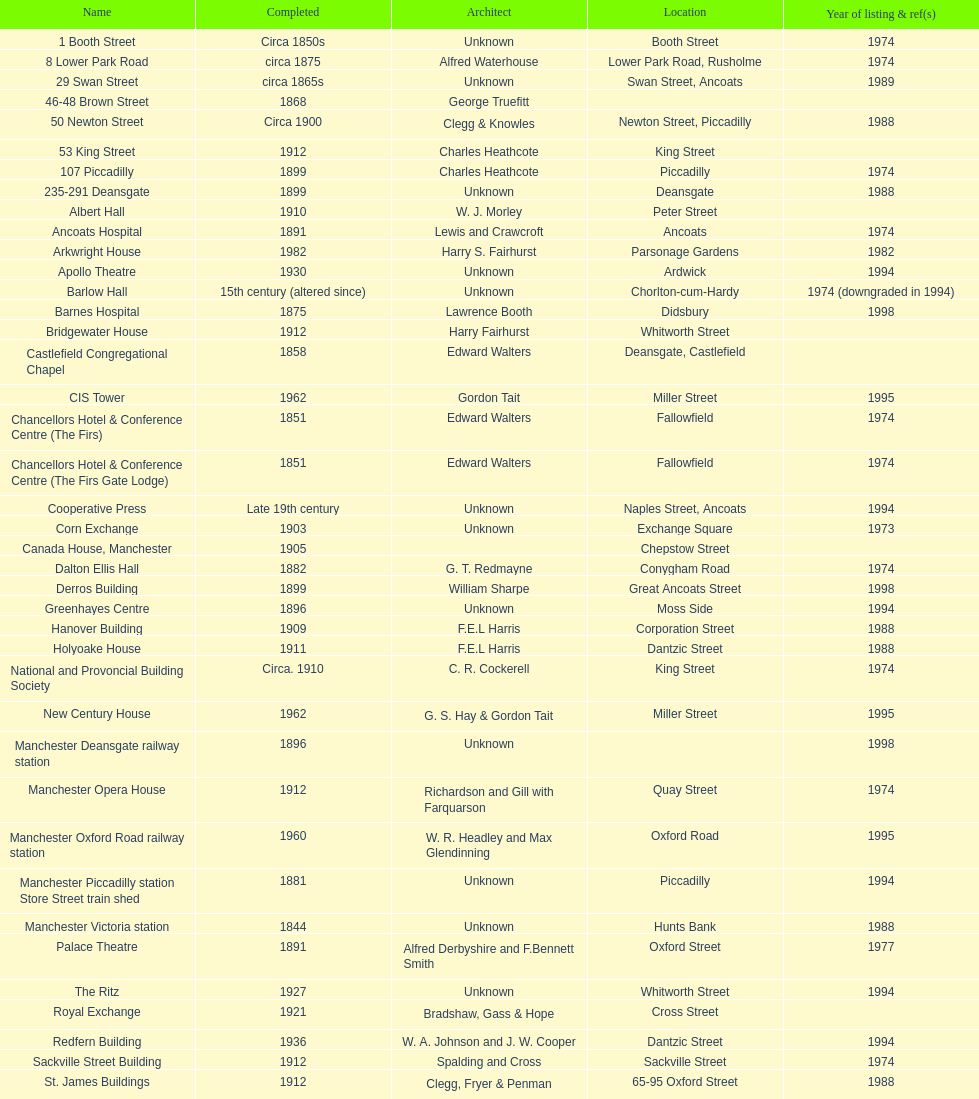How many buildings had alfred waterhouse as their architect? 3. 